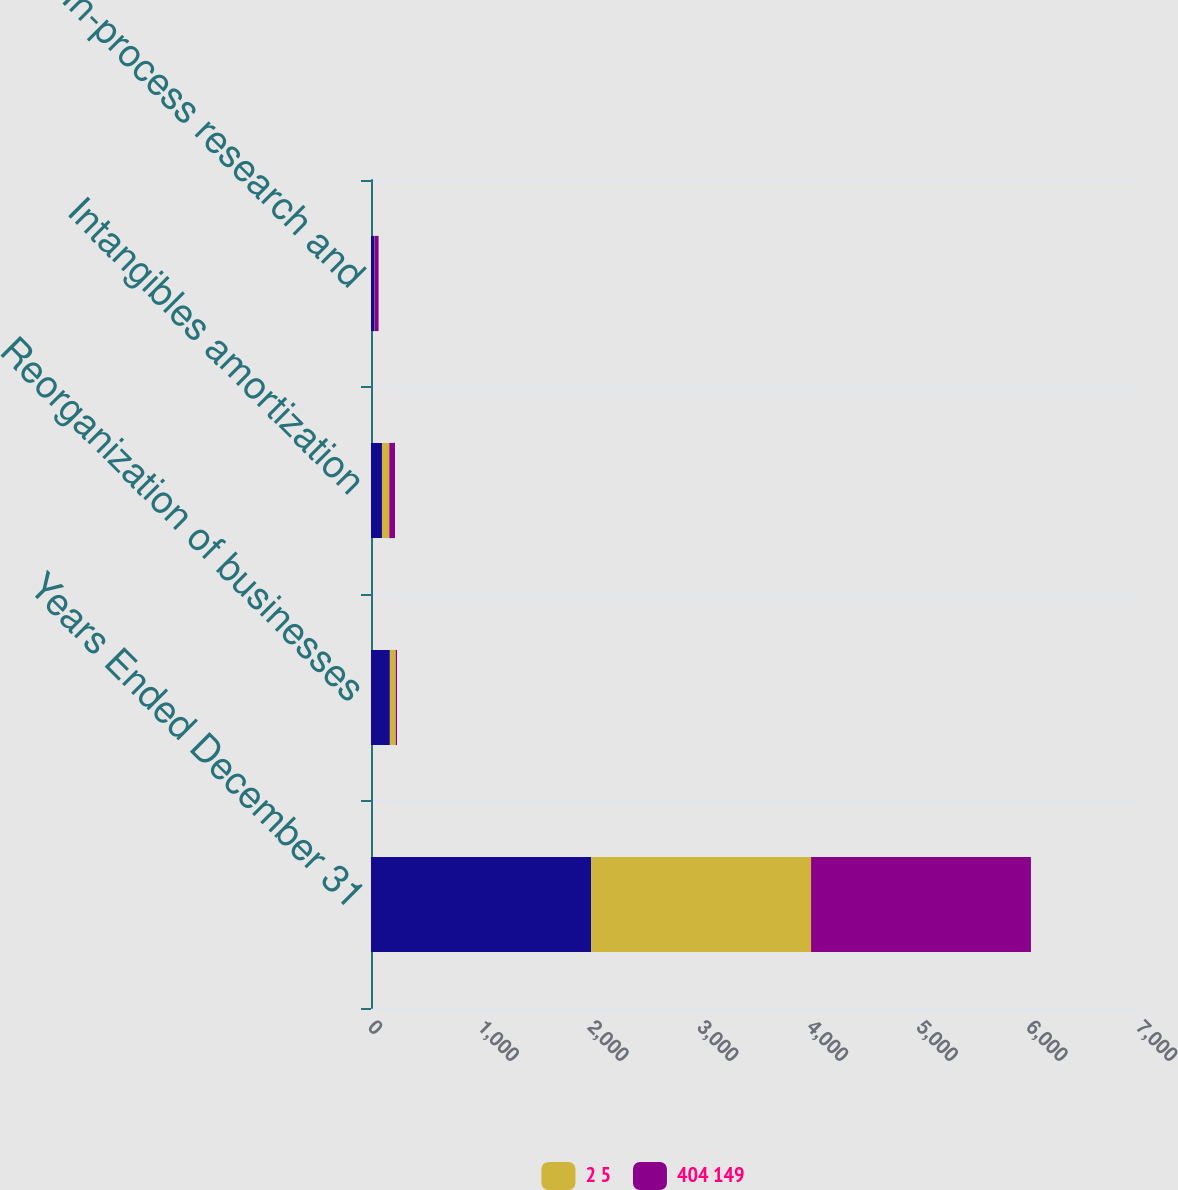Convert chart. <chart><loc_0><loc_0><loc_500><loc_500><stacked_bar_chart><ecel><fcel>Years Ended December 31<fcel>Reorganization of businesses<fcel>Intangibles amortization<fcel>In-process research and<nl><fcel>nan<fcel>2006<fcel>172<fcel>100<fcel>33<nl><fcel>2 5<fcel>2005<fcel>54<fcel>67<fcel>2<nl><fcel>404 149<fcel>2004<fcel>11<fcel>52<fcel>34<nl></chart> 